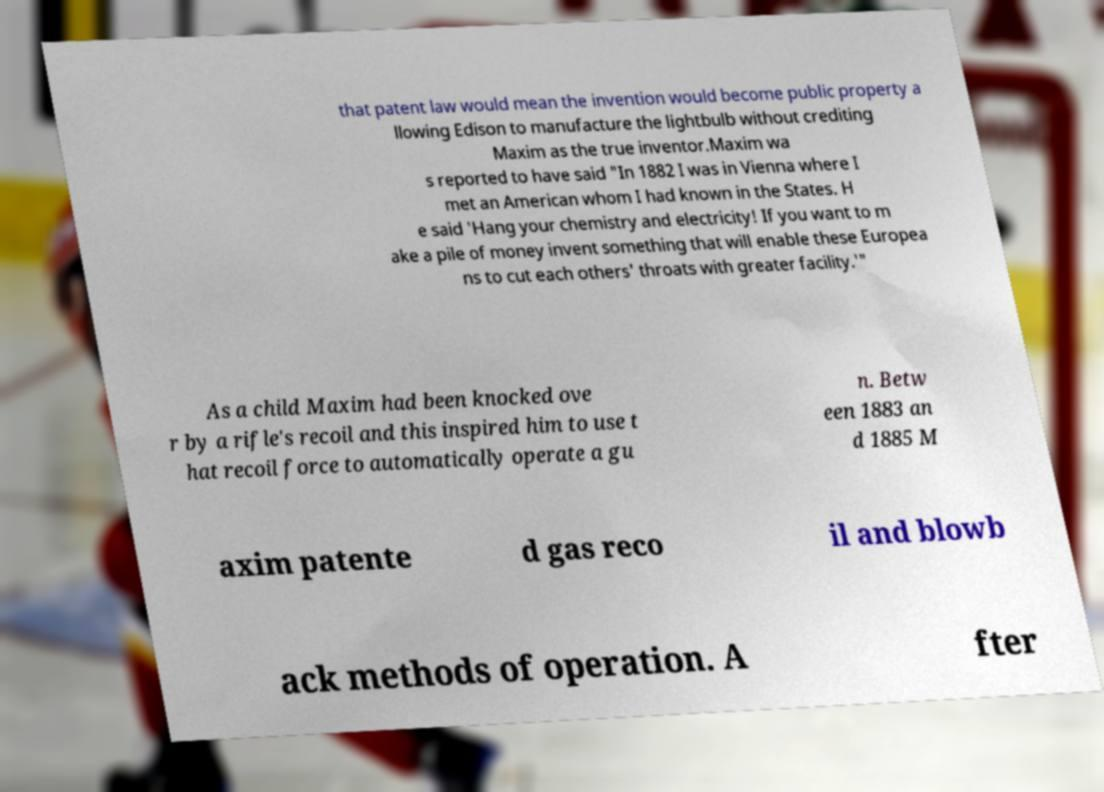For documentation purposes, I need the text within this image transcribed. Could you provide that? that patent law would mean the invention would become public property a llowing Edison to manufacture the lightbulb without crediting Maxim as the true inventor.Maxim wa s reported to have said "In 1882 I was in Vienna where I met an American whom I had known in the States. H e said 'Hang your chemistry and electricity! If you want to m ake a pile of money invent something that will enable these Europea ns to cut each others' throats with greater facility.'" As a child Maxim had been knocked ove r by a rifle's recoil and this inspired him to use t hat recoil force to automatically operate a gu n. Betw een 1883 an d 1885 M axim patente d gas reco il and blowb ack methods of operation. A fter 